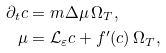<formula> <loc_0><loc_0><loc_500><loc_500>\partial _ { t } c & = m \Delta \mu \, \Omega _ { T } , \\ \mu & = \mathcal { L } _ { \varepsilon } c + f ^ { \prime } ( c ) \, \Omega _ { T } ,</formula> 